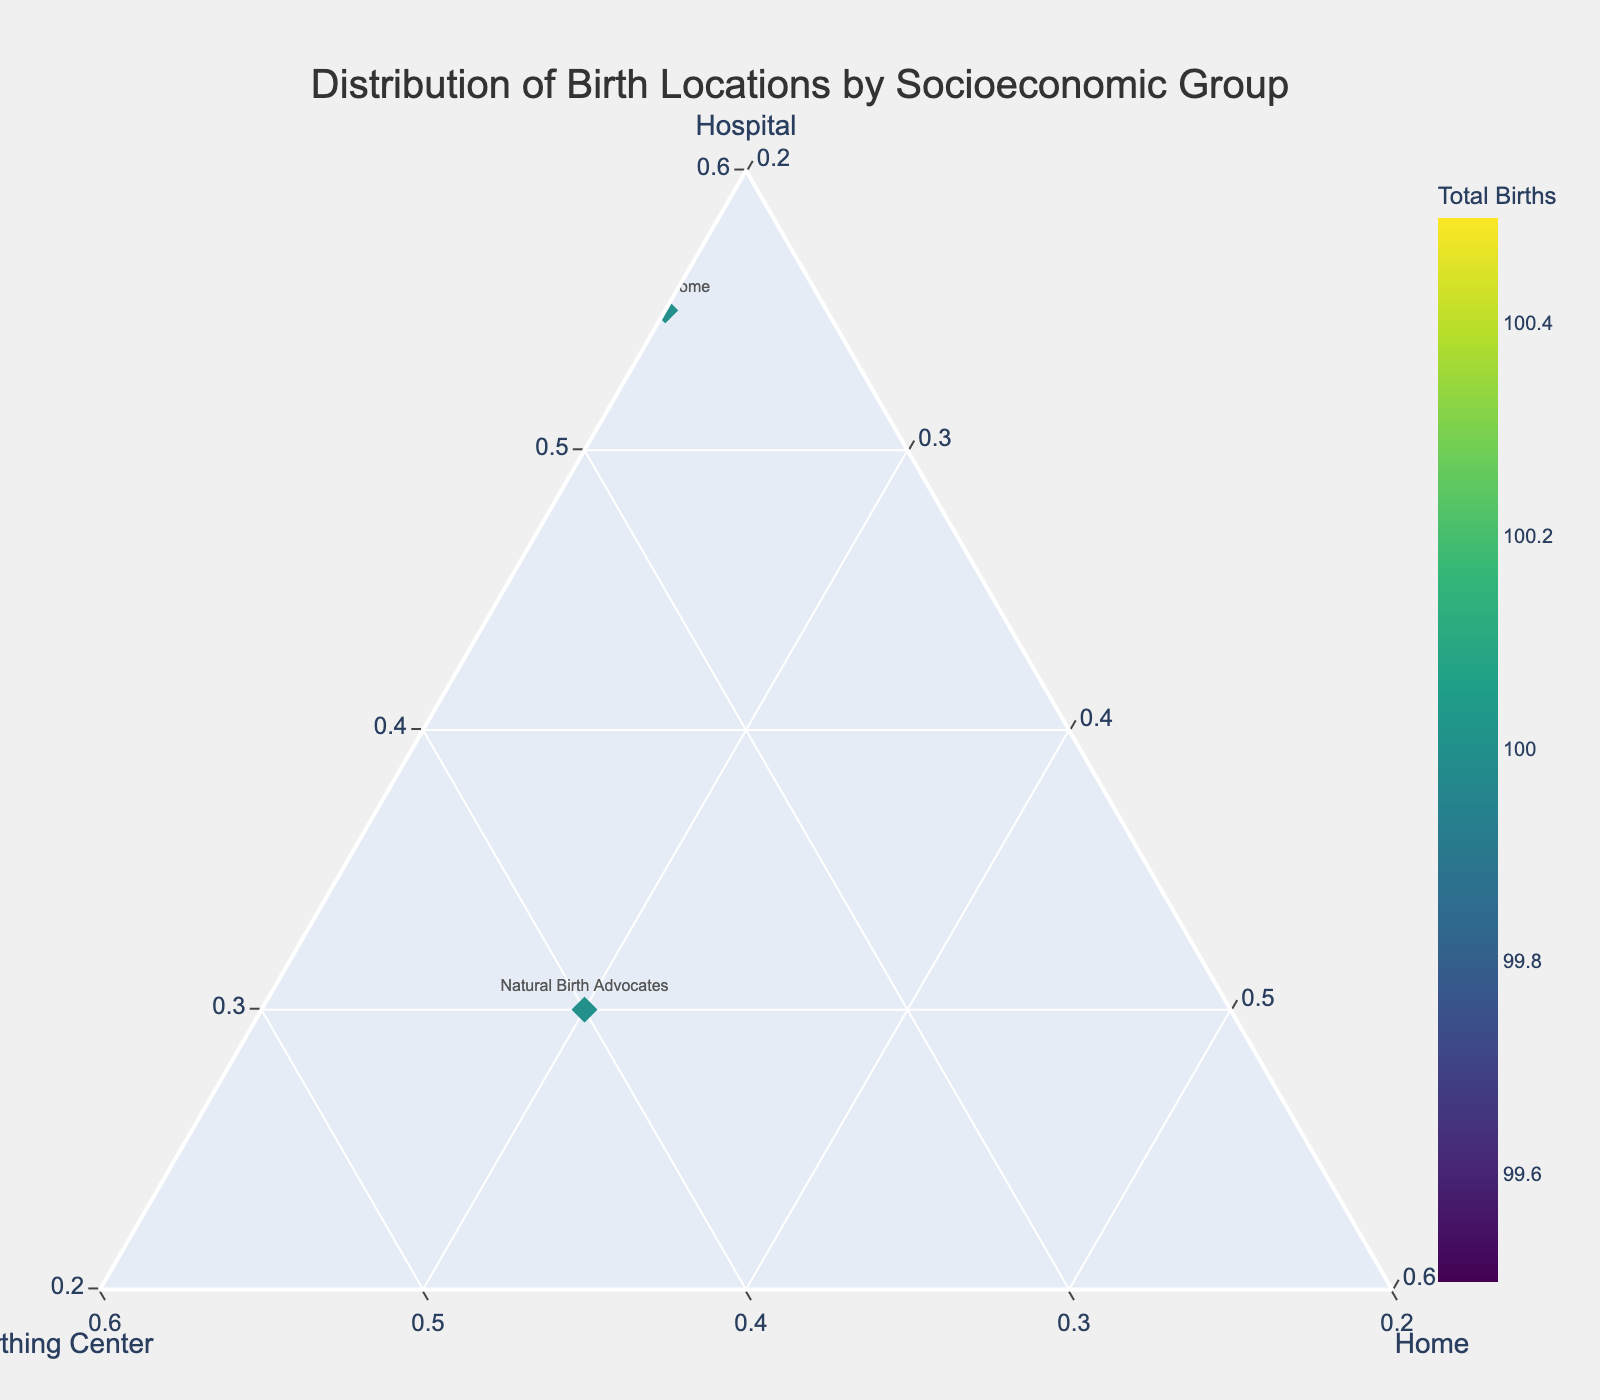How many socioeconomic groups are represented in the plot? Count the number of unique categories listed as 'Socioeconomic Group'.
Answer: 15 Which group has the highest percentage of home births? Look for the data point positioned closest to the "Home" axis. This would be the "Natural Birth Advocates" group, as it shifts towards home births.
Answer: Natural Birth Advocates Compare the proportion of hospital births between 'High Income' and 'Low Income' groups. Which group has a lower percentage? Examine the data points for 'High Income' and 'Low Income' and see which one is positioned further from the 'Hospital' axis. 'High Income' has a lower percentage of hospital births compared to 'Low Income'.
Answer: High Income What's the median value of the percentage of birthing center births across all groups? Order the percentages of birthing center births for all groups: (5, 7, 8, 10, 12, 15, 20, 25, 25, 25, 30, 30, 35, 40, 40). The median value is the one in the middle of the ordered list, which is the 8th value.
Answer: 25 Which groups have the same percentage distribution for birthing locations? Identify the groups with identical coordinates in the ternary plot. 'Lower Middle Class' and 'LGBTQ+ Families' both have a distribution of 75% (hospital), 20% (birthing center), and 5% (home).
Answer: Lower Middle Class and LGBTQ+ Families Which socioeconomic group has the highest total number of births? Refer to the color legend to identify the data point with the darkest color, representing the highest number of births. This would be 'Immigrant Communities'.
Answer: Immigrant Communities What is the average proportion of home births for 'Upper Middle Class' and 'Rural Communities'? Add the proportions of home births for 'Upper Middle Class' (0.10) and 'Rural Communities' (0.15), then divide by 2. \( \frac{0.10 + 0.15}{2} = 0.125 \).
Answer: 0.125 Which group is situated closest to the center of the ternary plot? Look for the data point that appears centrally balanced between hospital, birthing center, and home. The "Suburban Families" group appears to have an almost even distribution.
Answer: Suburban Families Are there any groups with less than 10% choosing home births? If yes, name them. Identify data points positioned near the 'Home' axis with values less than 10%. 'Low Income', 'Lower Middle Class', 'Middle Class', 'Urban Poor', 'College-Educated', 'Experienced Mothers', 'Single Mothers', and 'LGBTQ+ Families' have less than 10%.
Answer: Yes, there are several: Low Income, Lower Middle Class, Middle Class, Urban Poor, College-Educated, Experienced Mothers, Single Mothers, LGBTQ+ Families What is the range of percentages for hospital births across all groups? Identify the maximum (90% for 'Urban Poor') and minimum (30% for 'Natural Birth Advocates') percentages of hospital births. Calculate the range by subtracting the minimum from the maximum: 90% - 30% = 60%.
Answer: 60% 